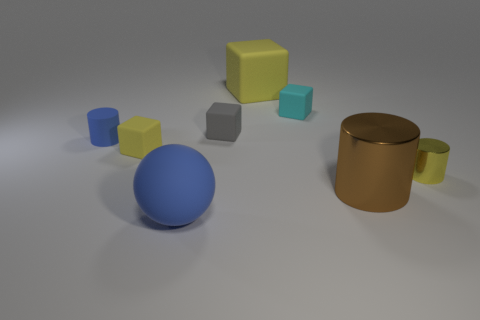Add 2 yellow metallic objects. How many objects exist? 10 Subtract all spheres. How many objects are left? 7 Add 2 blue balls. How many blue balls exist? 3 Subtract 1 brown cylinders. How many objects are left? 7 Subtract all green matte things. Subtract all large rubber cubes. How many objects are left? 7 Add 1 cyan blocks. How many cyan blocks are left? 2 